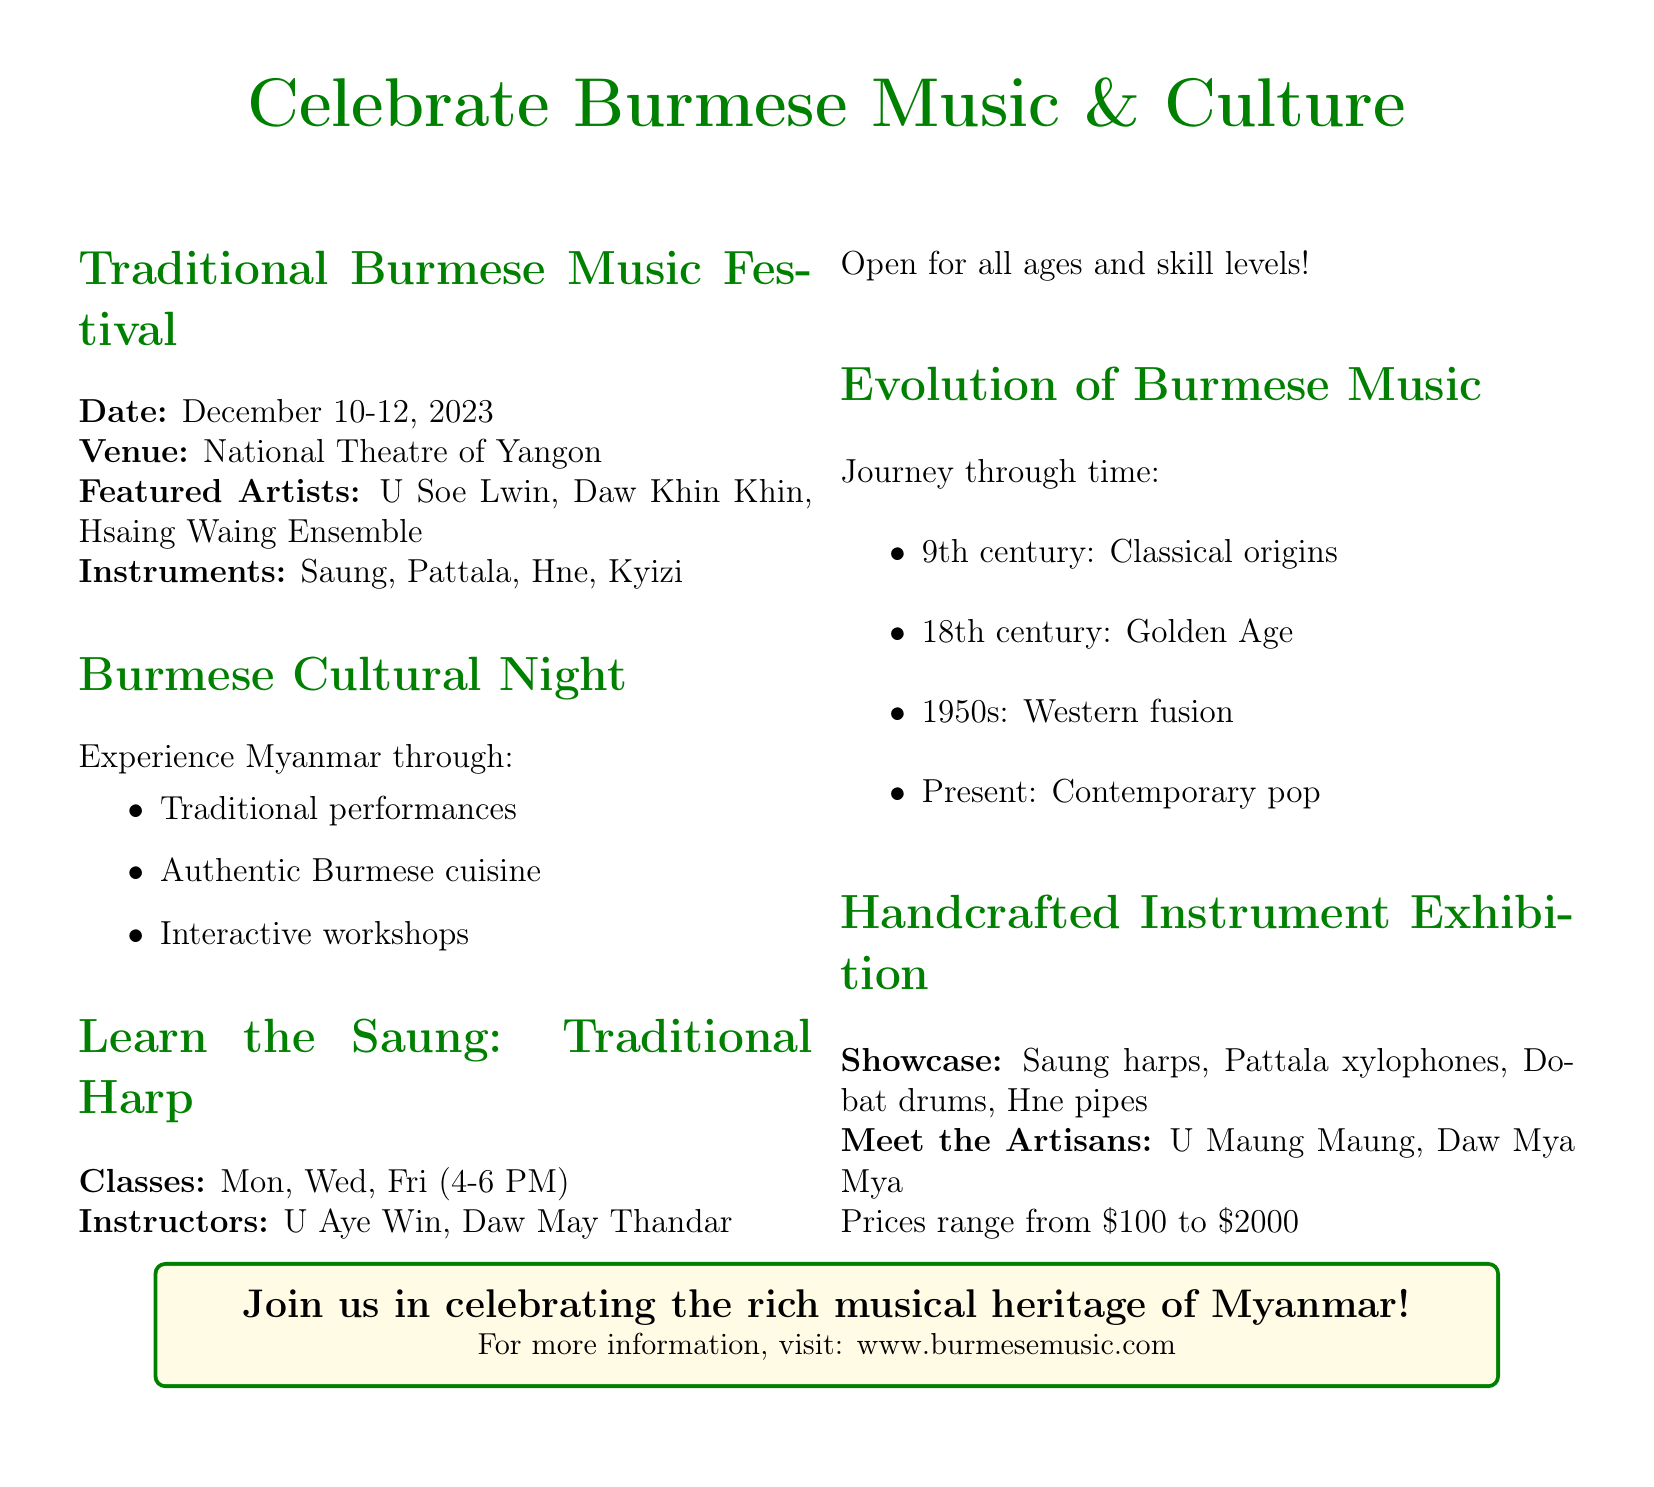What are the dates of the Traditional Burmese Music Festival? The dates of the festival are explicitly stated in the document: December 10-12, 2023.
Answer: December 10-12, 2023 Where is the event taking place? The venue of the event is mentioned clearly in the document, which is the National Theatre of Yangon.
Answer: National Theatre of Yangon Who are the featured artists at the festival? The document lists the featured artists under the section about the festival, which are U Soe Lwin, Daw Khin Khin, and Hsaing Waing Ensemble.
Answer: U Soe Lwin, Daw Khin Khin, Hsaing Waing Ensemble What traditional instrument is taught in the "Learn the Saung" classes? The class specified in the document is focused on the Saung, which is the traditional Burmese harp.
Answer: Saung Which centuries are mentioned in the evolution of Burmese music? The document provides multiple time periods in the evolution section: 9th century, 18th century, and 1950s.
Answer: 9th century, 18th century, 1950s If someone wants to learn the Saung, which days are classes held? The schedule for the Saung classes is found in the document, indicating the classes occur on Mondays, Wednesdays, and Fridays.
Answer: Mon, Wed, Fri What is the price range for handcrafted instruments at the exhibition? The document states that prices for these instruments range from $100 to $2000.
Answer: $100 to $2000 What types of performances can one expect at the Burmese Cultural Night? The document lists traditional performances as one of the highlights of the Burmese Cultural Night.
Answer: Traditional performances Who are the instructors for the Saung classes? The instructors for the Saung classes are named in the document as U Aye Win and Daw May Thandar.
Answer: U Aye Win, Daw May Thandar 